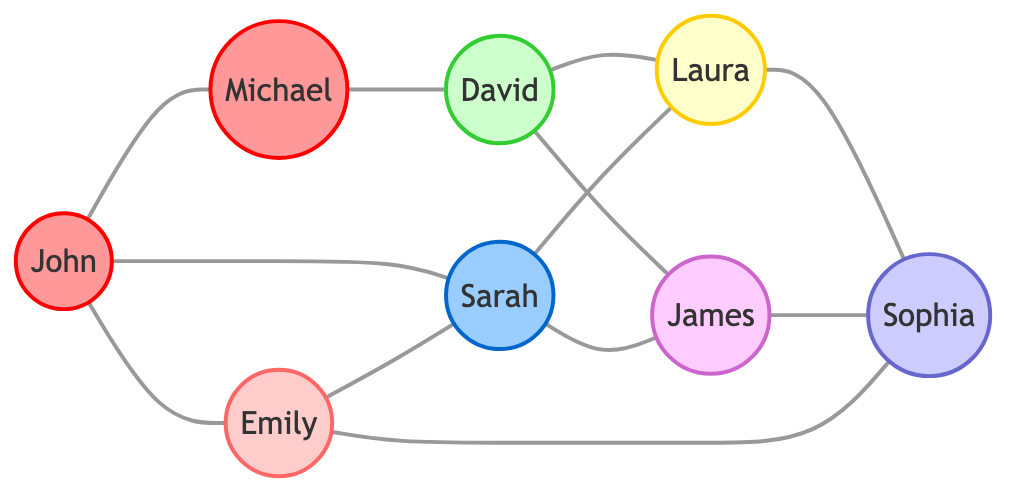How many nodes are in the graph? The graph contains a total of 8 nodes, which are John, Emily, Michael, Sarah, David, Laura, James, and Sophia.
Answer: 8 Which player is connected to Emily? Emily is connected to John, Sarah, and Sophia based on the edges from the graph.
Answer: John, Sarah, Sophia What is the attribute of David? The diagram indicates that David is a computer science major, which is stated in the node attribute.
Answer: computer science major How many edges are connected to Sarah? Sarah has 4 edges connecting her to John, Emily, Laura, and James, indicating her connections in the graph.
Answer: 4 Who is connected to both David and Laura? The only person connected to both David and Laura is Sarah, based on the edges shown in the graph.
Answer: Sarah Which major is the most connected within the graph? In examining the edges, David (computer science major) and Sarah (resident assistant) each connect to multiple other nodes, but David connects to Laura and James, making him the most connected major.
Answer: computer science major Is there a direct connection between Michael and Sophia? Michael is not directly connected to Sophia, as the edges connecting to Michael do not include Sophia.
Answer: No Which two people share a mutual connection through Sarah? Emily and James both have a direct connection through Sarah, making them mutual friends in this network.
Answer: Emily and James How many football players are in the graph? The graph shows that there are 2 nodes categorized as football players: John and Michael.
Answer: 2 